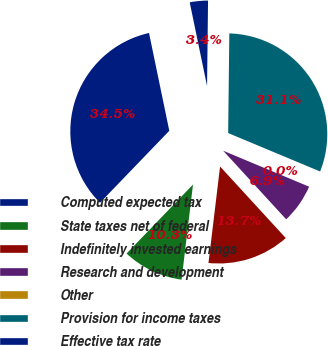<chart> <loc_0><loc_0><loc_500><loc_500><pie_chart><fcel>Computed expected tax<fcel>State taxes net of federal<fcel>Indefinitely invested earnings<fcel>Research and development<fcel>Other<fcel>Provision for income taxes<fcel>Effective tax rate<nl><fcel>34.55%<fcel>10.3%<fcel>13.73%<fcel>6.87%<fcel>0.01%<fcel>31.12%<fcel>3.44%<nl></chart> 